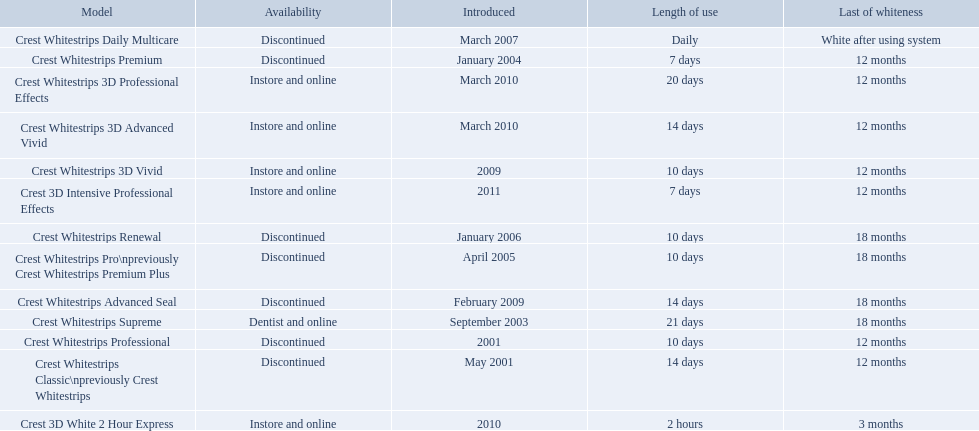When was crest whitestrips 3d advanced vivid introduced? March 2010. What other product was introduced in march 2010? Crest Whitestrips 3D Professional Effects. 